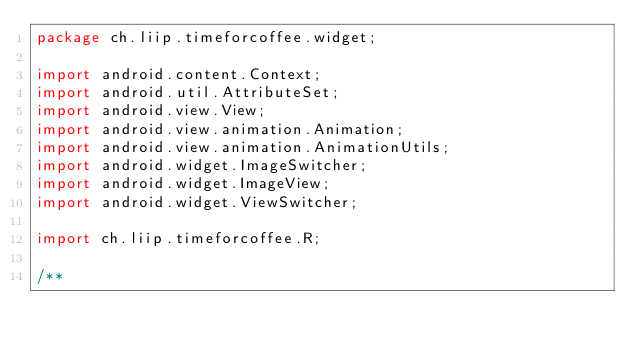Convert code to text. <code><loc_0><loc_0><loc_500><loc_500><_Java_>package ch.liip.timeforcoffee.widget;

import android.content.Context;
import android.util.AttributeSet;
import android.view.View;
import android.view.animation.Animation;
import android.view.animation.AnimationUtils;
import android.widget.ImageSwitcher;
import android.widget.ImageView;
import android.widget.ViewSwitcher;

import ch.liip.timeforcoffee.R;

/**</code> 